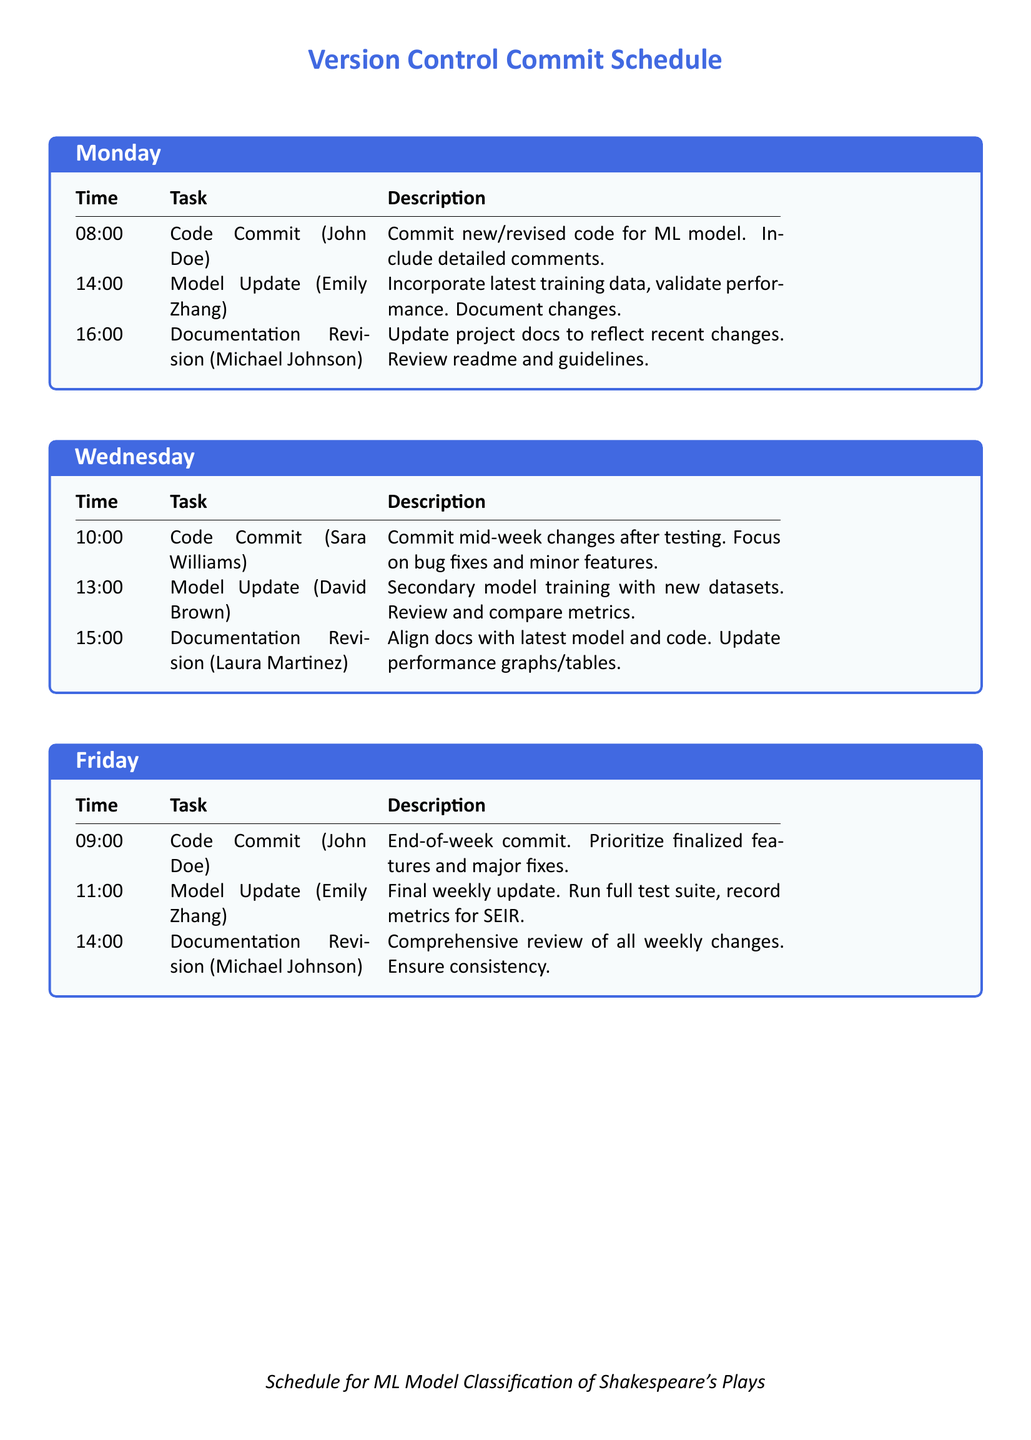What time is the first code commit on Monday? The first code commit on Monday is scheduled for 08:00.
Answer: 08:00 Who is responsible for the model update on Wednesday? The model update on Wednesday is handled by David Brown.
Answer: David Brown What task occurs at 14:00 on Monday? The task at 14:00 on Monday is a model update.
Answer: Model Update How many documentation revisions are scheduled per week? There are three documentation revisions scheduled each week (one each on Monday, Wednesday, and Friday).
Answer: Three What is the focus of the code commit on Wednesday? The focus of the code commit on Wednesday is on bug fixes and minor features.
Answer: Bug fixes and minor features What time is the final model update of the week? The final model update of the week occurs at 11:00 on Friday.
Answer: 11:00 Who performs the comprehensive review of documentation on Friday? The comprehensive review of documentation on Friday is performed by Michael Johnson.
Answer: Michael Johnson What is the main priority for the code commit on Friday? The main priority for the code commit on Friday is finalized features and major fixes.
Answer: Finalized features and major fixes 